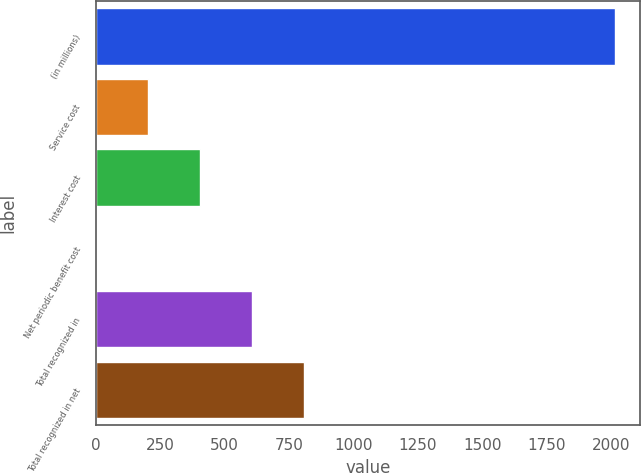<chart> <loc_0><loc_0><loc_500><loc_500><bar_chart><fcel>(in millions)<fcel>Service cost<fcel>Interest cost<fcel>Net periodic benefit cost<fcel>Total recognized in<fcel>Total recognized in net<nl><fcel>2014<fcel>203.2<fcel>404.4<fcel>2<fcel>605.6<fcel>806.8<nl></chart> 